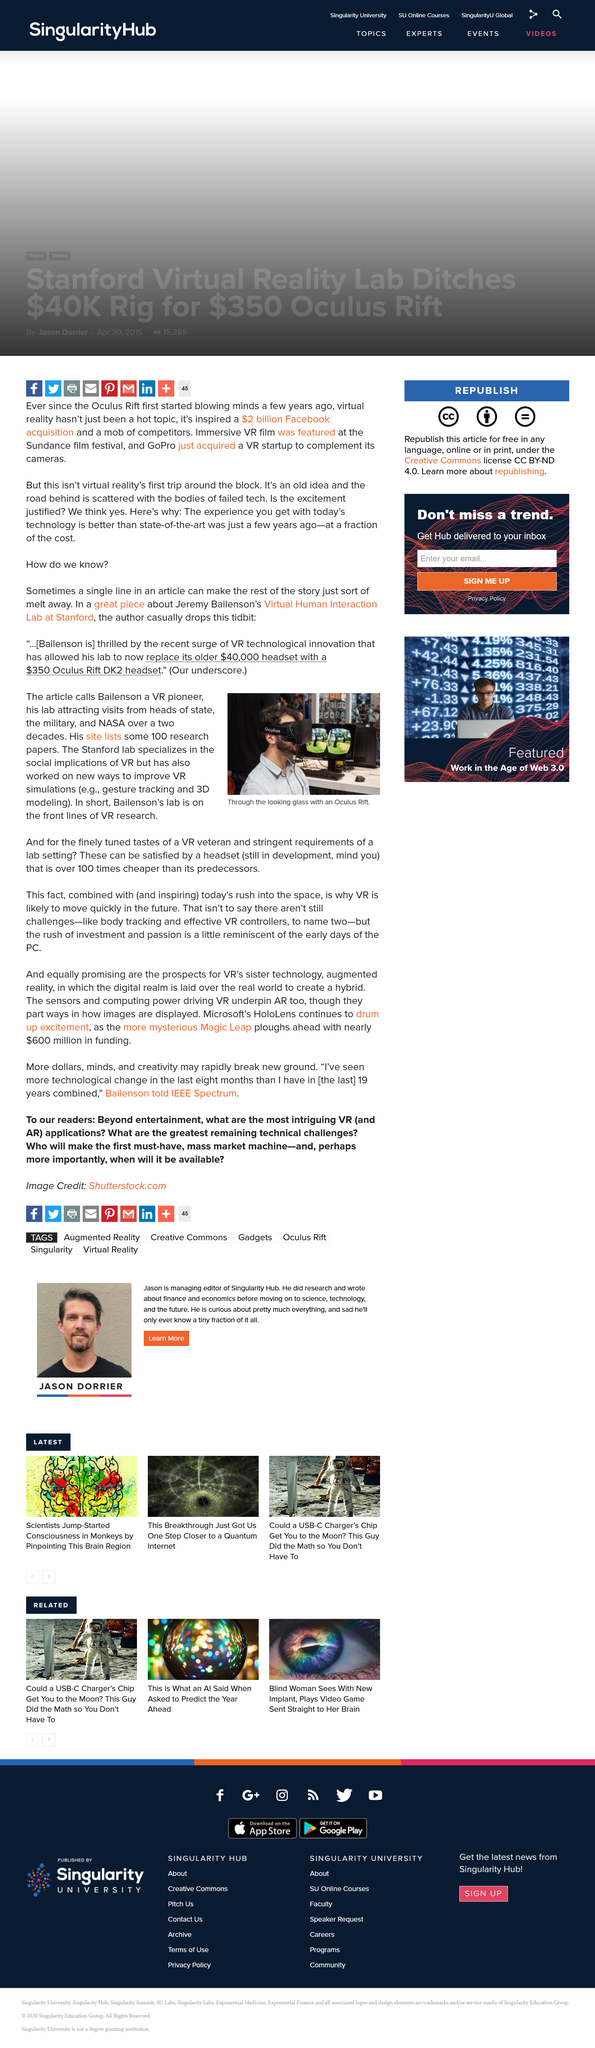Specify some key components in this picture. Bailenson's lab is located at Stanford University. The likely advancement of VR is imminent and will undoubtedly revolutionize the way we interact with technology. Occulus Rift is a virtual reality headset that utilizes advanced technology to create an immersive, computer-generated environment for users to experience. 